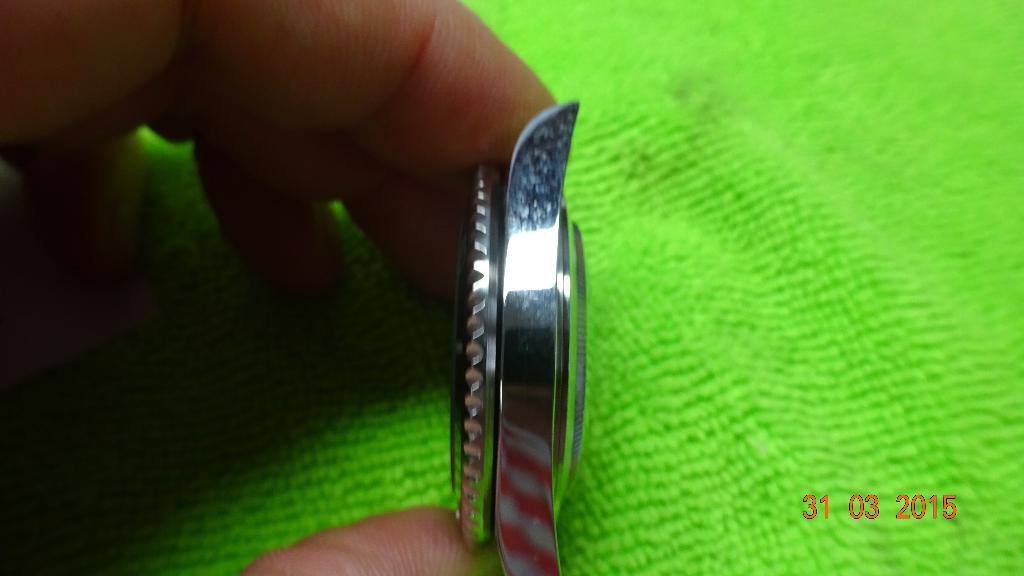When was this taken?
Your answer should be compact. 31 03 2015. 